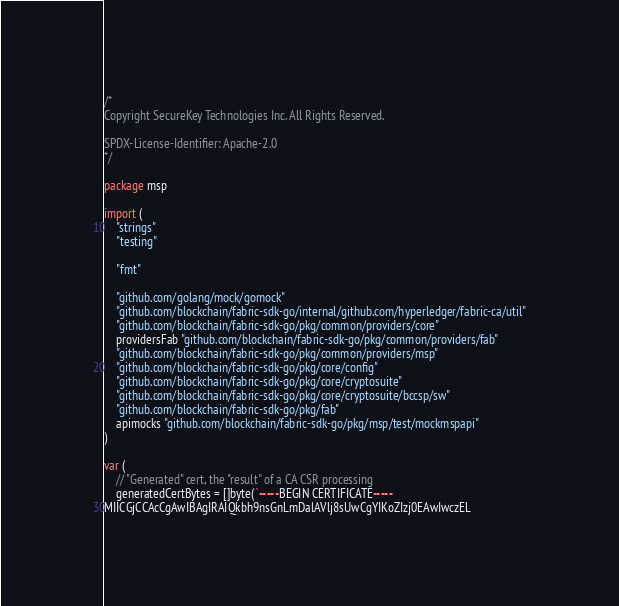<code> <loc_0><loc_0><loc_500><loc_500><_Go_>/*
Copyright SecureKey Technologies Inc. All Rights Reserved.

SPDX-License-Identifier: Apache-2.0
*/

package msp

import (
	"strings"
	"testing"

	"fmt"

	"github.com/golang/mock/gomock"
	"github.com/blockchain/fabric-sdk-go/internal/github.com/hyperledger/fabric-ca/util"
	"github.com/blockchain/fabric-sdk-go/pkg/common/providers/core"
	providersFab "github.com/blockchain/fabric-sdk-go/pkg/common/providers/fab"
	"github.com/blockchain/fabric-sdk-go/pkg/common/providers/msp"
	"github.com/blockchain/fabric-sdk-go/pkg/core/config"
	"github.com/blockchain/fabric-sdk-go/pkg/core/cryptosuite"
	"github.com/blockchain/fabric-sdk-go/pkg/core/cryptosuite/bccsp/sw"
	"github.com/blockchain/fabric-sdk-go/pkg/fab"
	apimocks "github.com/blockchain/fabric-sdk-go/pkg/msp/test/mockmspapi"
)

var (
	// "Generated" cert, the "result" of a CA CSR processing
	generatedCertBytes = []byte(`-----BEGIN CERTIFICATE-----
MIICGjCCAcCgAwIBAgIRAIQkbh9nsGnLmDalAVlj8sUwCgYIKoZIzj0EAwIwczEL</code> 